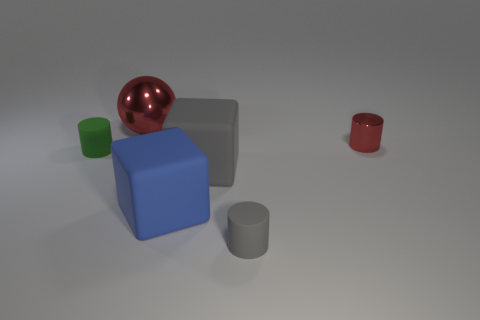Add 1 large green metal things. How many objects exist? 7 Subtract all cubes. How many objects are left? 4 Add 4 blue matte cubes. How many blue matte cubes exist? 5 Subtract 0 yellow cubes. How many objects are left? 6 Subtract all blue rubber blocks. Subtract all big shiny objects. How many objects are left? 4 Add 2 large metallic spheres. How many large metallic spheres are left? 3 